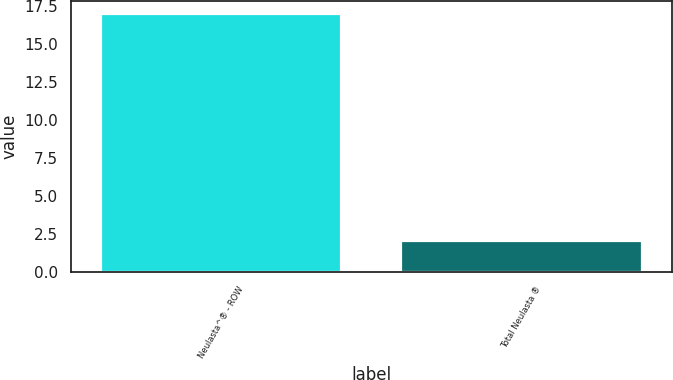Convert chart to OTSL. <chart><loc_0><loc_0><loc_500><loc_500><bar_chart><fcel>Neulasta^® - ROW<fcel>Total Neulasta ®<nl><fcel>17<fcel>2<nl></chart> 